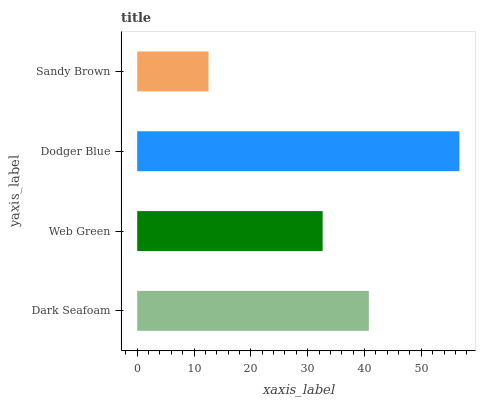Is Sandy Brown the minimum?
Answer yes or no. Yes. Is Dodger Blue the maximum?
Answer yes or no. Yes. Is Web Green the minimum?
Answer yes or no. No. Is Web Green the maximum?
Answer yes or no. No. Is Dark Seafoam greater than Web Green?
Answer yes or no. Yes. Is Web Green less than Dark Seafoam?
Answer yes or no. Yes. Is Web Green greater than Dark Seafoam?
Answer yes or no. No. Is Dark Seafoam less than Web Green?
Answer yes or no. No. Is Dark Seafoam the high median?
Answer yes or no. Yes. Is Web Green the low median?
Answer yes or no. Yes. Is Sandy Brown the high median?
Answer yes or no. No. Is Dark Seafoam the low median?
Answer yes or no. No. 